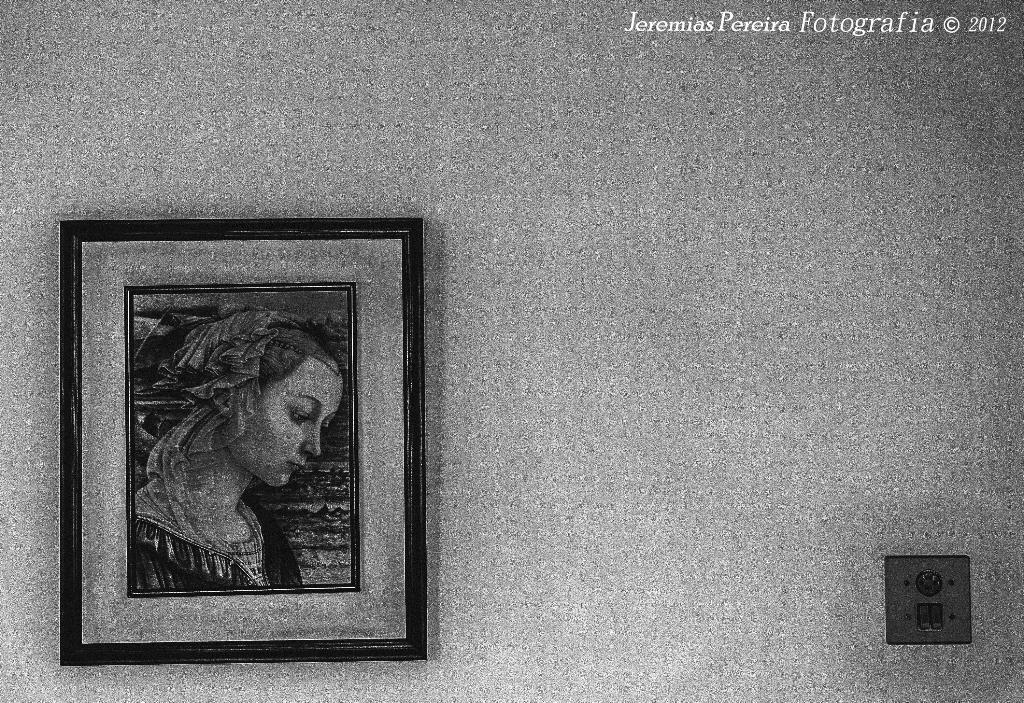What can be seen on the left side of the image? There is a photo frame on the left side of the image. What is located on the right side of the image? There is an object on the right side of the image. What is visible in the background of the image? There is a wall in the background of the image. What is written or displayed at the top of the image? There is text visible at the top of the image. Can you see a seashore in the image? No, there is no seashore present in the image. Is there a lamp visible in the image? No, there is no lamp present in the image. 